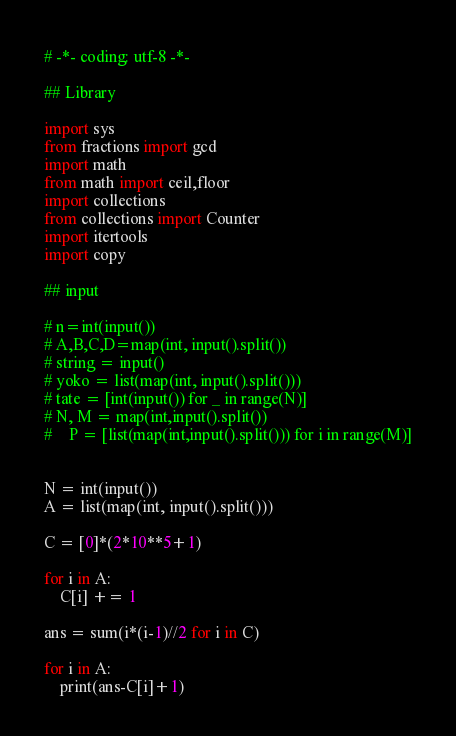Convert code to text. <code><loc_0><loc_0><loc_500><loc_500><_Python_># -*- coding: utf-8 -*-

## Library

import sys
from fractions import gcd
import math
from math import ceil,floor
import collections
from collections import Counter
import itertools
import copy

## input

# n=int(input())
# A,B,C,D=map(int, input().split())
# string = input()
# yoko = list(map(int, input().split()))
# tate = [int(input()) for _ in range(N)]
# N, M = map(int,input().split()) 
#    P = [list(map(int,input().split())) for i in range(M)]


N = int(input())
A = list(map(int, input().split()))

C = [0]*(2*10**5+1)

for i in A:
    C[i] += 1

ans = sum(i*(i-1)//2 for i in C)

for i in A:
    print(ans-C[i]+1)</code> 